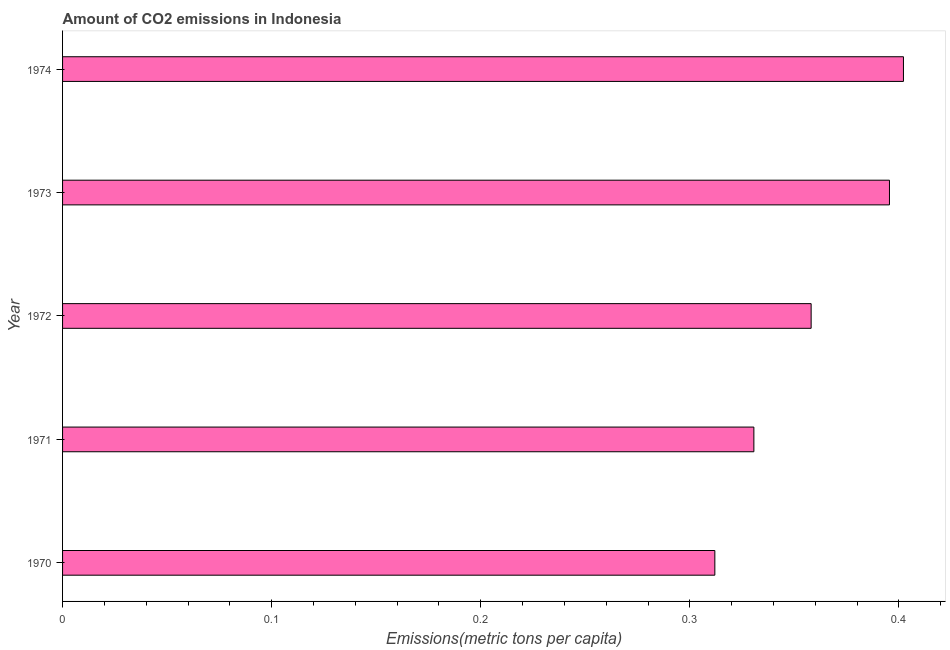Does the graph contain any zero values?
Your response must be concise. No. What is the title of the graph?
Offer a terse response. Amount of CO2 emissions in Indonesia. What is the label or title of the X-axis?
Keep it short and to the point. Emissions(metric tons per capita). What is the amount of co2 emissions in 1970?
Offer a terse response. 0.31. Across all years, what is the maximum amount of co2 emissions?
Make the answer very short. 0.4. Across all years, what is the minimum amount of co2 emissions?
Offer a very short reply. 0.31. In which year was the amount of co2 emissions maximum?
Provide a short and direct response. 1974. In which year was the amount of co2 emissions minimum?
Offer a very short reply. 1970. What is the sum of the amount of co2 emissions?
Keep it short and to the point. 1.8. What is the difference between the amount of co2 emissions in 1970 and 1972?
Provide a succinct answer. -0.05. What is the average amount of co2 emissions per year?
Your response must be concise. 0.36. What is the median amount of co2 emissions?
Provide a succinct answer. 0.36. What is the ratio of the amount of co2 emissions in 1971 to that in 1974?
Offer a very short reply. 0.82. Is the amount of co2 emissions in 1973 less than that in 1974?
Offer a very short reply. Yes. What is the difference between the highest and the second highest amount of co2 emissions?
Make the answer very short. 0.01. What is the difference between the highest and the lowest amount of co2 emissions?
Your answer should be very brief. 0.09. How many years are there in the graph?
Ensure brevity in your answer.  5. What is the difference between two consecutive major ticks on the X-axis?
Ensure brevity in your answer.  0.1. What is the Emissions(metric tons per capita) of 1970?
Offer a very short reply. 0.31. What is the Emissions(metric tons per capita) in 1971?
Ensure brevity in your answer.  0.33. What is the Emissions(metric tons per capita) of 1972?
Your answer should be very brief. 0.36. What is the Emissions(metric tons per capita) of 1973?
Your answer should be very brief. 0.4. What is the Emissions(metric tons per capita) in 1974?
Offer a terse response. 0.4. What is the difference between the Emissions(metric tons per capita) in 1970 and 1971?
Your answer should be compact. -0.02. What is the difference between the Emissions(metric tons per capita) in 1970 and 1972?
Keep it short and to the point. -0.05. What is the difference between the Emissions(metric tons per capita) in 1970 and 1973?
Give a very brief answer. -0.08. What is the difference between the Emissions(metric tons per capita) in 1970 and 1974?
Provide a short and direct response. -0.09. What is the difference between the Emissions(metric tons per capita) in 1971 and 1972?
Your answer should be compact. -0.03. What is the difference between the Emissions(metric tons per capita) in 1971 and 1973?
Offer a very short reply. -0.06. What is the difference between the Emissions(metric tons per capita) in 1971 and 1974?
Ensure brevity in your answer.  -0.07. What is the difference between the Emissions(metric tons per capita) in 1972 and 1973?
Ensure brevity in your answer.  -0.04. What is the difference between the Emissions(metric tons per capita) in 1972 and 1974?
Give a very brief answer. -0.04. What is the difference between the Emissions(metric tons per capita) in 1973 and 1974?
Your response must be concise. -0.01. What is the ratio of the Emissions(metric tons per capita) in 1970 to that in 1971?
Provide a short and direct response. 0.94. What is the ratio of the Emissions(metric tons per capita) in 1970 to that in 1972?
Ensure brevity in your answer.  0.87. What is the ratio of the Emissions(metric tons per capita) in 1970 to that in 1973?
Give a very brief answer. 0.79. What is the ratio of the Emissions(metric tons per capita) in 1970 to that in 1974?
Offer a terse response. 0.78. What is the ratio of the Emissions(metric tons per capita) in 1971 to that in 1972?
Your answer should be very brief. 0.92. What is the ratio of the Emissions(metric tons per capita) in 1971 to that in 1973?
Offer a very short reply. 0.84. What is the ratio of the Emissions(metric tons per capita) in 1971 to that in 1974?
Offer a very short reply. 0.82. What is the ratio of the Emissions(metric tons per capita) in 1972 to that in 1973?
Give a very brief answer. 0.91. What is the ratio of the Emissions(metric tons per capita) in 1972 to that in 1974?
Your answer should be very brief. 0.89. 